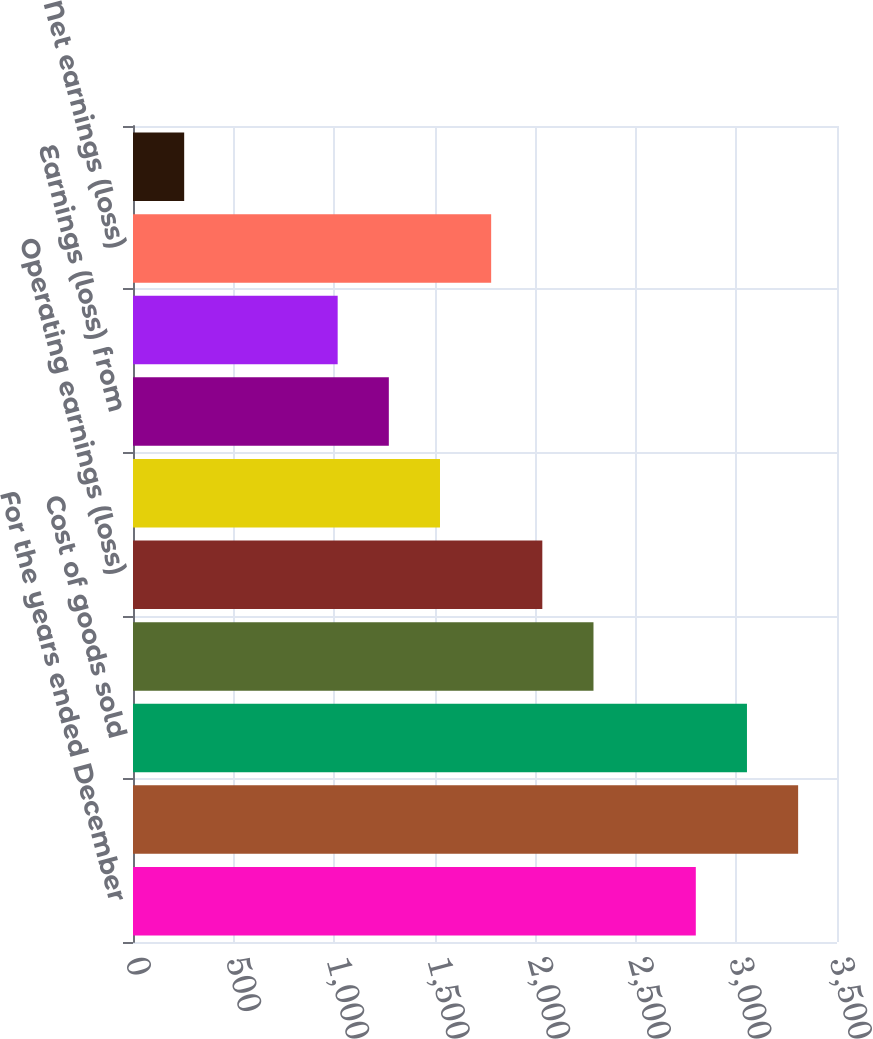<chart> <loc_0><loc_0><loc_500><loc_500><bar_chart><fcel>For the years ended December<fcel>Net sales<fcel>Cost of goods sold<fcel>Gross profit<fcel>Operating earnings (loss)<fcel>before income taxes<fcel>Earnings (loss) from<fcel>net of income taxes<fcel>Net earnings (loss)<fcel>Continuing operations<nl><fcel>2798.05<fcel>3306.77<fcel>3052.41<fcel>2289.33<fcel>2034.97<fcel>1526.25<fcel>1271.89<fcel>1017.53<fcel>1780.61<fcel>254.45<nl></chart> 